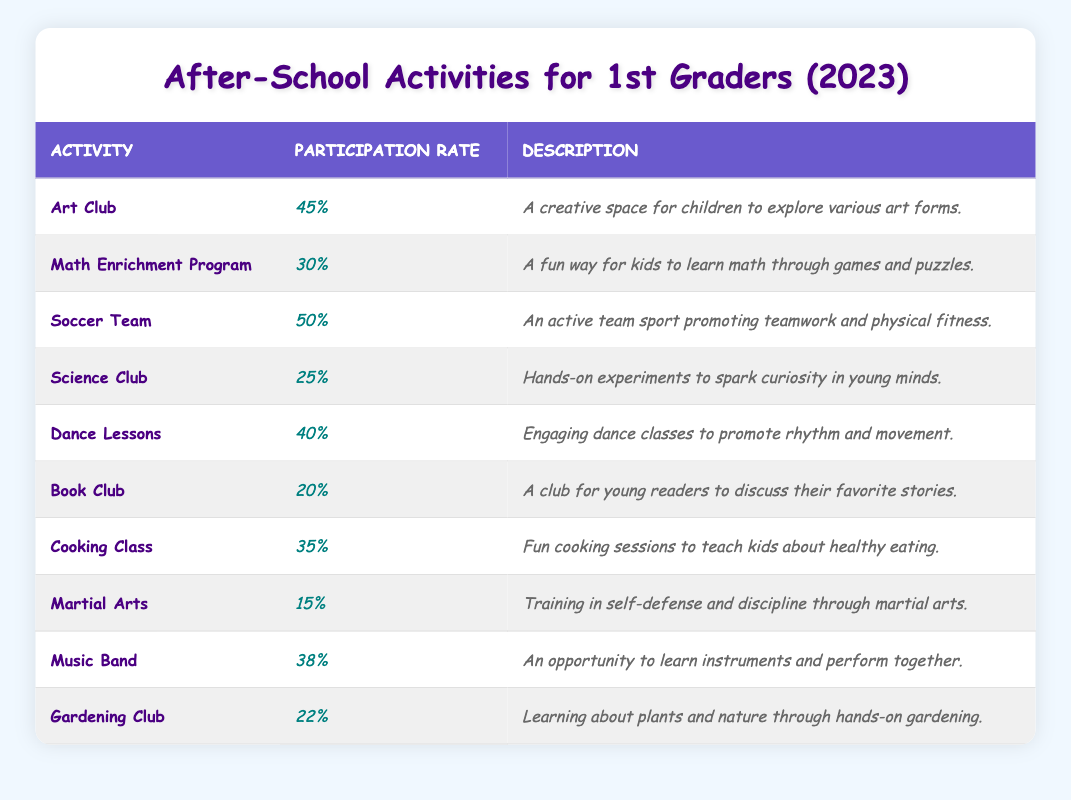What is the participation rate for the Soccer Team? The table shows that the participation rate for the Soccer Team is 50%.
Answer: 50% Which activity has the highest participation rate? The highest participation rate is seen in the Soccer Team, which is 50%.
Answer: Soccer Team Is the participation rate for the Dance Lessons higher than that for the Science Club? The participation rate for Dance Lessons is 40%, and for Science Club, it is 25%. Since 40% is greater than 25%, the answer is yes.
Answer: Yes What is the average participation rate of the Art Club and the Cooking Class? The participation rate for the Art Club is 45% and for Cooking Class is 35%. To find the average, (45 + 35) / 2 = 80 / 2 = 40%.
Answer: 40% Which two activities have participation rates above 40%? The activities with participation rates above 40% are Soccer Team (50%) and Art Club (45%).
Answer: Soccer Team and Art Club How many activities have a participation rate lower than 30%? The activities with participation rates lower than 30% are the Science Club (25%), Book Club (20%), and Martial Arts (15%). There are 3 such activities.
Answer: 3 If you combine the participation rates of Music Band and Gardening Club, what is the total? The participation rate for Music Band is 38% and for Gardening Club is 22%. Adding them gives 38 + 22 = 60%.
Answer: 60% Which activity has a participation rate that is exactly 5% less than Dance Lessons? The participation rate for Dance Lessons is 40%. If we subtract 5%, we look for an activity with a rate of 35%. The Cooking Class has a participation rate of 35%.
Answer: Cooking Class Do more students participate in the Book Club than in Martial Arts? The participation rate for the Book Club is 20%, and for Martial Arts, it is 15%. Since 20% is greater than 15%, the answer is yes.
Answer: Yes What is the difference in participation rates between the highest and lowest activities? The highest participation rate is 50% for the Soccer Team, and the lowest is 15% for the Martial Arts. The difference is 50 - 15 = 35%.
Answer: 35% 